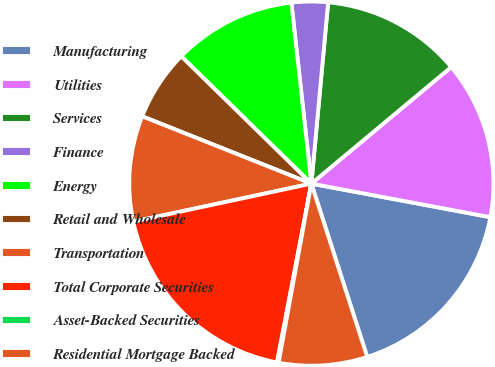<chart> <loc_0><loc_0><loc_500><loc_500><pie_chart><fcel>Manufacturing<fcel>Utilities<fcel>Services<fcel>Finance<fcel>Energy<fcel>Retail and Wholesale<fcel>Transportation<fcel>Total Corporate Securities<fcel>Asset-Backed Securities<fcel>Residential Mortgage Backed<nl><fcel>17.09%<fcel>14.01%<fcel>12.47%<fcel>3.22%<fcel>10.92%<fcel>6.3%<fcel>9.38%<fcel>18.63%<fcel>0.14%<fcel>7.84%<nl></chart> 